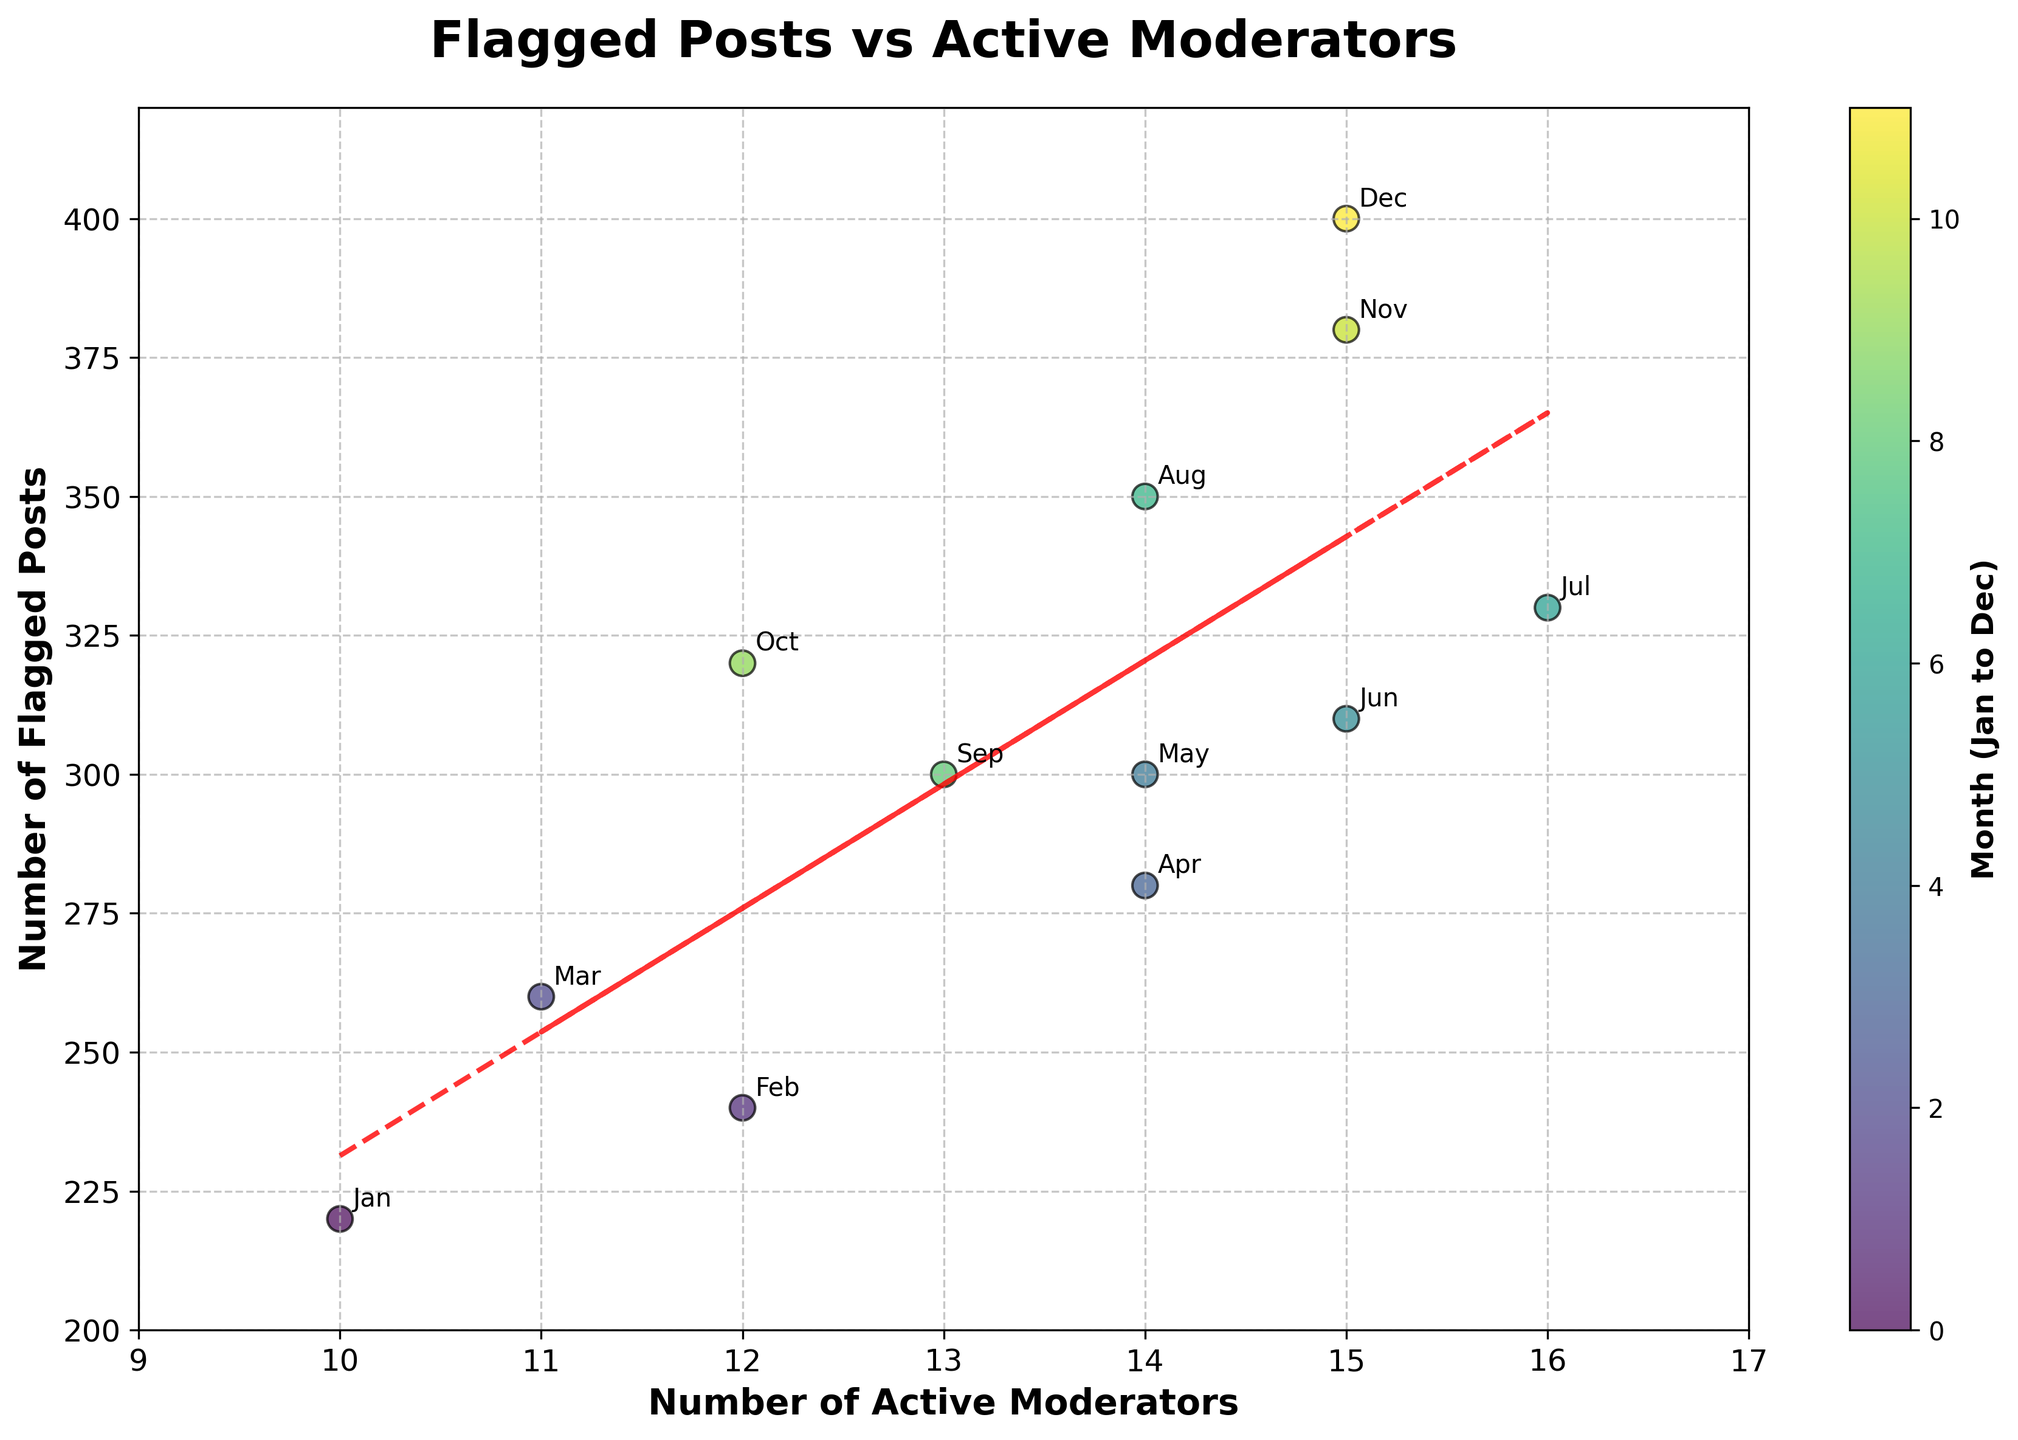What is the title of the plot? The title of the plot is located at the top center, visually shown in large font. It reads "Flagged Posts vs Active Moderators".
Answer: Flagged Posts vs Active Moderators What is the trend line showing? The trend line, depicted as a red dashed line, indicates a positive linear relationship between the number of active moderators and the number of flagged posts.
Answer: Positive linear trend Which month had the highest number of flagged posts? By checking the "Number of Flagged Posts" axis and the month annotations, December has the highest value, reaching 400 flagged posts.
Answer: December How many active moderators were there in March? Locate the month "March" on the plot and refer to the corresponding "Number of Active Moderators" value. March had 11 active moderators.
Answer: 11 Is there a month where the number of flagged posts decreases while the number of active moderators increases? Check the plotted points and annotations: August shows a scenario where the flagged posts decrease to 350 while active moderators are 14, compared to their higher numbers in earlier months like July.
Answer: August What is the approximate slope of the trend line? The slope can be derived from the trend line equation \(y = mx + c\). From visual inspection or approximate calculation, the slope (m) is around 10.
Answer: 10 Which month witnessed the smallest increase in flagged posts relative to the previous month? By comparing the month-to-month increments visually on the plotted scatter points: September shows the smallest increase, perhaps even a decrease in flagged posts.
Answer: September How many months had 15 active moderators? Check the scatter plot annotations: June, November, and December each had 15 active moderators.
Answer: 3 What's the difference in the number of flagged posts between February and April? February had 240 flagged posts and April had 280, so the difference is 280 - 240 = 40.
Answer: 40 Compare the number of flagged posts in July and October; which one is higher? Refer to their respective markers: July had 330 flagged posts, and October had 320. Therefore, July is higher.
Answer: July 